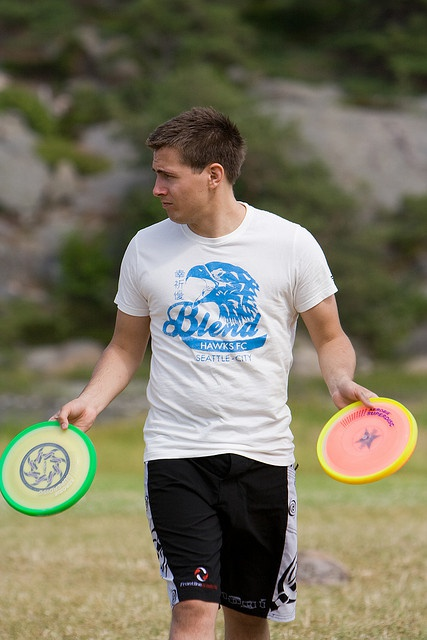Describe the objects in this image and their specific colors. I can see people in darkgreen, lightgray, black, darkgray, and gray tones, frisbee in darkgreen, khaki, darkgray, and lightgreen tones, and frisbee in darkgreen, lightpink, khaki, tan, and gold tones in this image. 